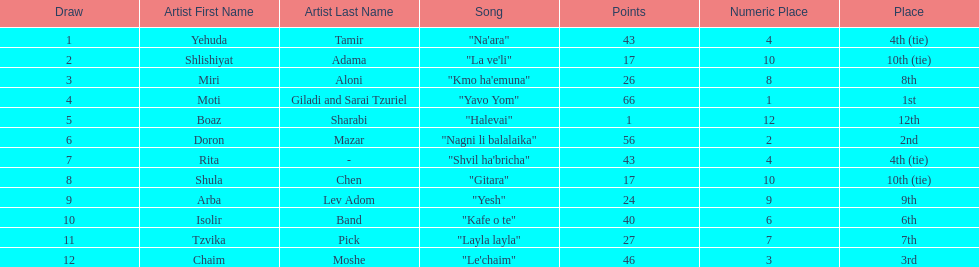I'm looking to parse the entire table for insights. Could you assist me with that? {'header': ['Draw', 'Artist First Name', 'Artist Last Name', 'Song', 'Points', 'Numeric Place', 'Place'], 'rows': [['1', 'Yehuda', 'Tamir', '"Na\'ara"', '43', '4', '4th (tie)'], ['2', 'Shlishiyat', 'Adama', '"La ve\'li"', '17', '10', '10th (tie)'], ['3', 'Miri', 'Aloni', '"Kmo ha\'emuna"', '26', '8', '8th'], ['4', 'Moti', 'Giladi and Sarai Tzuriel', '"Yavo Yom"', '66', '1', '1st'], ['5', 'Boaz', 'Sharabi', '"Halevai"', '1', '12', '12th'], ['6', 'Doron', 'Mazar', '"Nagni li balalaika"', '56', '2', '2nd'], ['7', 'Rita', '-', '"Shvil ha\'bricha"', '43', '4', '4th (tie)'], ['8', 'Shula', 'Chen', '"Gitara"', '17', '10', '10th (tie)'], ['9', 'Arba', 'Lev Adom', '"Yesh"', '24', '9', '9th'], ['10', 'Isolir', 'Band', '"Kafe o te"', '40', '6', '6th'], ['11', 'Tzvika', 'Pick', '"Layla layla"', '27', '7', '7th'], ['12', 'Chaim', 'Moshe', '"Le\'chaim"', '46', '3', '3rd']]} What are the number of times an artist earned first place? 1. 